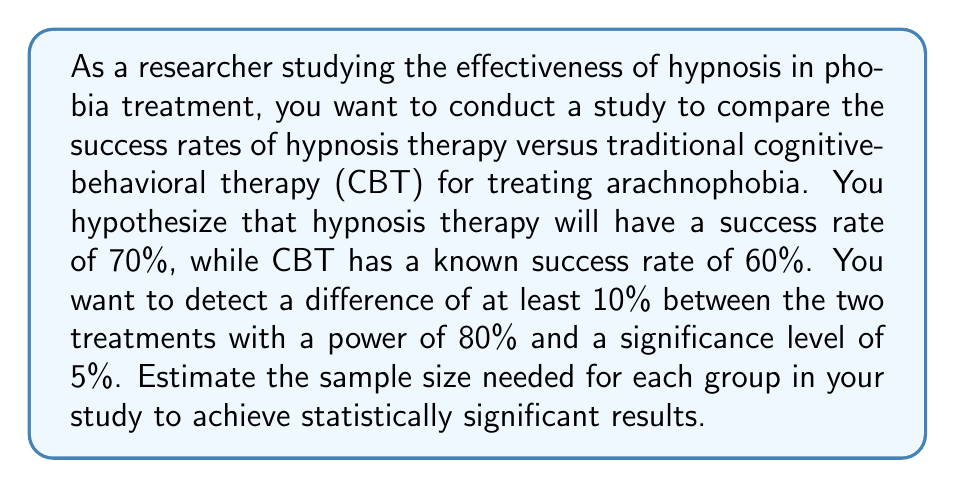Solve this math problem. To estimate the sample size needed for this study, we'll use the formula for comparing two proportions:

$$ n = \frac{(z_{\alpha/2} + z_{\beta})^2 [p_1(1-p_1) + p_2(1-p_2)]}{(p_1 - p_2)^2} $$

Where:
- $n$ is the sample size for each group
- $z_{\alpha/2}$ is the critical value of the normal distribution at $\alpha/2$
- $z_{\beta}$ is the critical value of the normal distribution at $\beta$
- $p_1$ is the expected proportion for hypnosis therapy (0.70)
- $p_2$ is the known proportion for CBT (0.60)

Given:
- Significance level $\alpha = 0.05$, so $z_{\alpha/2} = 1.96$
- Power $= 1 - \beta = 0.80$, so $\beta = 0.20$ and $z_{\beta} = 0.84$
- $p_1 = 0.70$ (hypnosis therapy)
- $p_2 = 0.60$ (CBT)

Plugging these values into the formula:

$$ n = \frac{(1.96 + 0.84)^2 [0.70(1-0.70) + 0.60(1-0.60)]}{(0.70 - 0.60)^2} $$

$$ n = \frac{7.84 [0.21 + 0.24]}{0.01} $$

$$ n = \frac{7.84 * 0.45}{0.01} $$

$$ n = 352.8 $$

Rounding up to the nearest whole number:

$$ n = 353 $$
Answer: The estimated sample size needed for each group (hypnosis therapy and CBT) is 353 participants. 